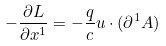Convert formula to latex. <formula><loc_0><loc_0><loc_500><loc_500>- \frac { \partial L } { \partial x ^ { 1 } } = - \frac { q } { c } u \cdot ( \partial ^ { 1 } A )</formula> 